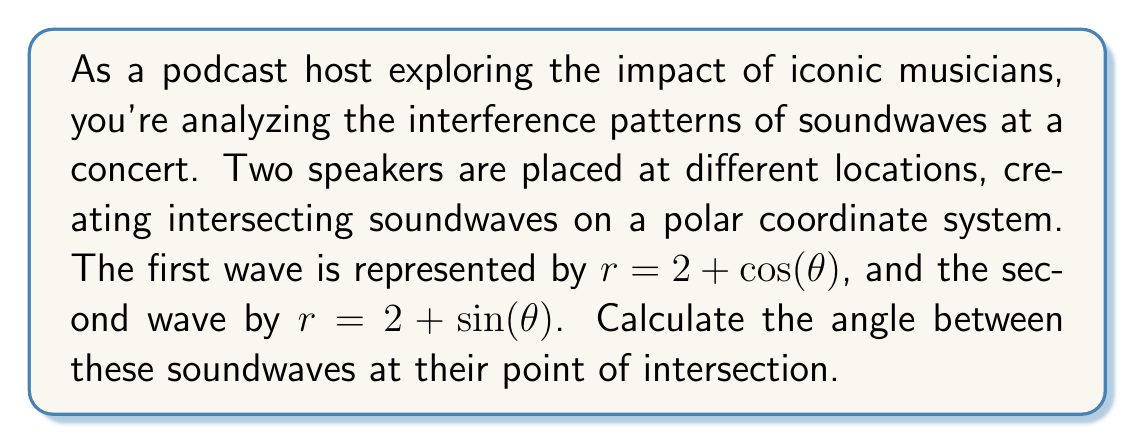Teach me how to tackle this problem. Let's approach this step-by-step:

1) First, we need to find the point of intersection. This occurs when the r-values are equal for both equations:

   $2 + \cos(\theta) = 2 + \sin(\theta)$

   $\cos(\theta) = \sin(\theta)$

   This occurs when $\theta = \frac{\pi}{4}$ (or 45°).

2) At the point of intersection, we need to find the tangent vectors for each curve. We can do this by differentiating the equations with respect to $\theta$:

   For $r = 2 + \cos(\theta)$: 
   $\frac{dr}{d\theta} = -\sin(\theta)$

   For $r = 2 + \sin(\theta)$: 
   $\frac{dr}{d\theta} = \cos(\theta)$

3) The tangent vectors in polar coordinates are:

   $\vec{v_1} = (2+\cos(\theta))\hat{r} - \sin(\theta)\hat{\theta}$
   $\vec{v_2} = (2+\sin(\theta))\hat{r} + \cos(\theta)\hat{\theta}$

4) At $\theta = \frac{\pi}{4}$, these become:

   $\vec{v_1} = (2+\frac{\sqrt{2}}{2})\hat{r} - \frac{\sqrt{2}}{2}\hat{\theta}$
   $\vec{v_2} = (2+\frac{\sqrt{2}}{2})\hat{r} + \frac{\sqrt{2}}{2}\hat{\theta}$

5) The angle between these vectors can be found using the dot product formula:

   $\cos(\phi) = \frac{\vec{v_1} \cdot \vec{v_2}}{|\vec{v_1}||\vec{v_2}|}$

6) Calculating the dot product:

   $\vec{v_1} \cdot \vec{v_2} = (2+\frac{\sqrt{2}}{2})^2 - (\frac{\sqrt{2}}{2})(\frac{\sqrt{2}}{2}) = 4 + 2\sqrt{2} + \frac{1}{2} - \frac{1}{2} = 4 + 2\sqrt{2}$

7) Calculating the magnitudes:

   $|\vec{v_1}| = |\vec{v_2}| = \sqrt{(2+\frac{\sqrt{2}}{2})^2 + (\frac{\sqrt{2}}{2})^2} = \sqrt{4 + 2\sqrt{2} + \frac{1}{2} + \frac{1}{2}} = \sqrt{5 + 2\sqrt{2}}$

8) Substituting into the dot product formula:

   $\cos(\phi) = \frac{4 + 2\sqrt{2}}{5 + 2\sqrt{2}}$

9) To find $\phi$, we take the inverse cosine:

   $\phi = \arccos(\frac{4 + 2\sqrt{2}}{5 + 2\sqrt{2}})$
Answer: $\arccos(\frac{4 + 2\sqrt{2}}{5 + 2\sqrt{2}})$ radians 